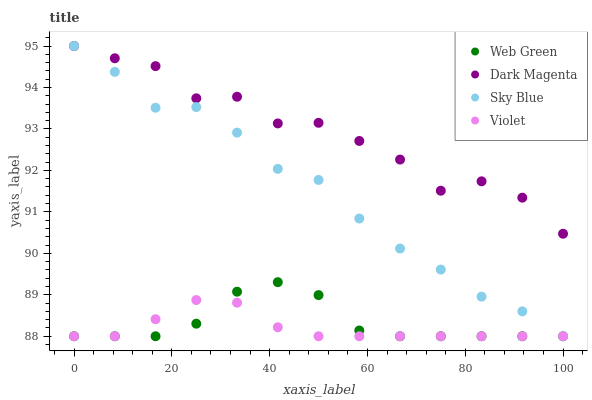Does Violet have the minimum area under the curve?
Answer yes or no. Yes. Does Dark Magenta have the maximum area under the curve?
Answer yes or no. Yes. Does Web Green have the minimum area under the curve?
Answer yes or no. No. Does Web Green have the maximum area under the curve?
Answer yes or no. No. Is Violet the smoothest?
Answer yes or no. Yes. Is Dark Magenta the roughest?
Answer yes or no. Yes. Is Web Green the smoothest?
Answer yes or no. No. Is Web Green the roughest?
Answer yes or no. No. Does Sky Blue have the lowest value?
Answer yes or no. Yes. Does Dark Magenta have the lowest value?
Answer yes or no. No. Does Dark Magenta have the highest value?
Answer yes or no. Yes. Does Web Green have the highest value?
Answer yes or no. No. Is Violet less than Dark Magenta?
Answer yes or no. Yes. Is Dark Magenta greater than Web Green?
Answer yes or no. Yes. Does Sky Blue intersect Web Green?
Answer yes or no. Yes. Is Sky Blue less than Web Green?
Answer yes or no. No. Is Sky Blue greater than Web Green?
Answer yes or no. No. Does Violet intersect Dark Magenta?
Answer yes or no. No. 